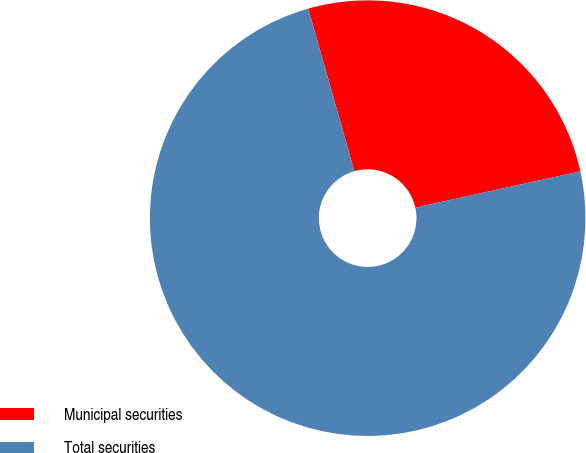<chart> <loc_0><loc_0><loc_500><loc_500><pie_chart><fcel>Municipal securities<fcel>Total securities<nl><fcel>25.95%<fcel>74.05%<nl></chart> 